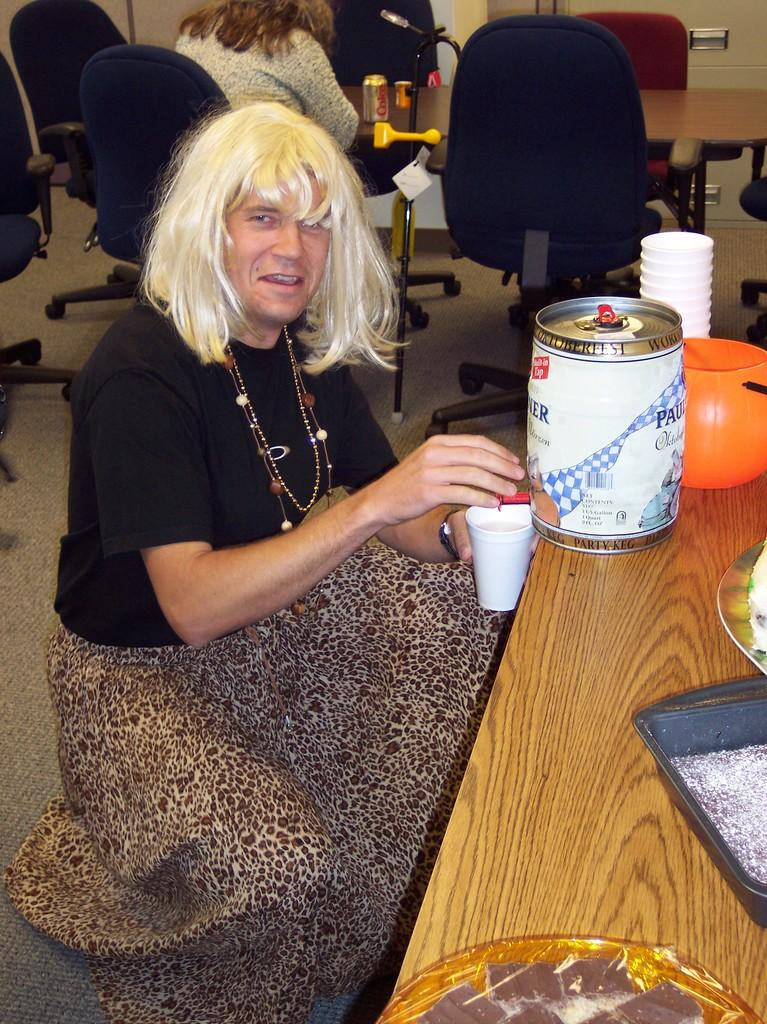What object is on the table in the image? There is a tin on the table in the image. What else is on the table besides the tin? There are glasses on the table. What is the person in the image doing with the tin? The person is taking water into a cup from the tin. Can you describe the setting in the background of the image? There are people, chairs, and tables in the background. How many cacti are visible in the image? There are no cacti present in the image. What type of wristwatch is the person wearing in the image? The person in the image is not wearing a wristwatch, as the focus is on the action of taking water from the tin. 